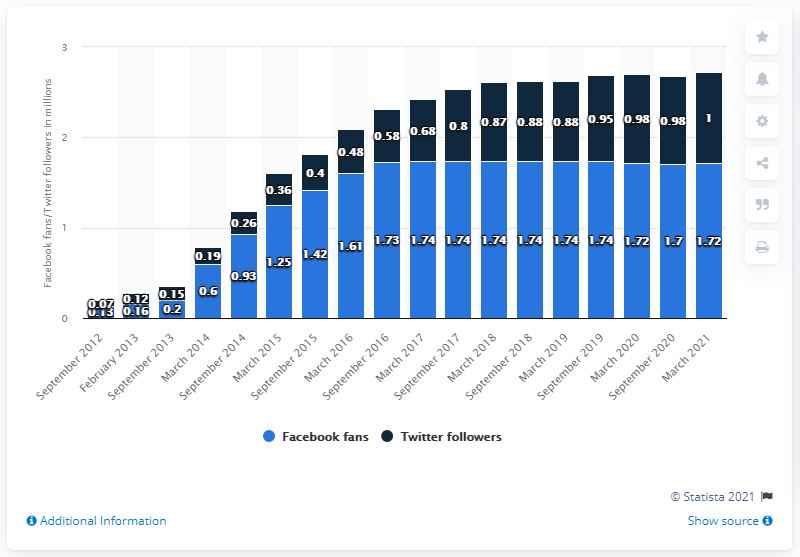Identify some key points in this picture. In March 2021, the Charlotte Hornets basketball team had 1.72 million fans on Facebook. 